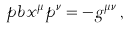Convert formula to latex. <formula><loc_0><loc_0><loc_500><loc_500>\ p b { x ^ { \mu } } { p ^ { \nu } } = - g ^ { \mu \nu } \, ,</formula> 